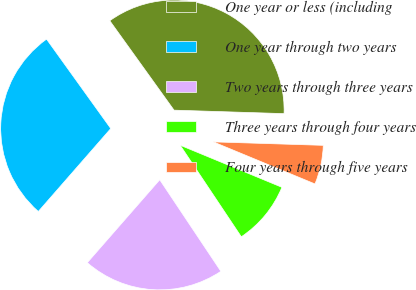<chart> <loc_0><loc_0><loc_500><loc_500><pie_chart><fcel>One year or less (including<fcel>One year through two years<fcel>Two years through three years<fcel>Three years through four years<fcel>Four years through five years<nl><fcel>35.42%<fcel>28.66%<fcel>20.8%<fcel>9.39%<fcel>5.74%<nl></chart> 